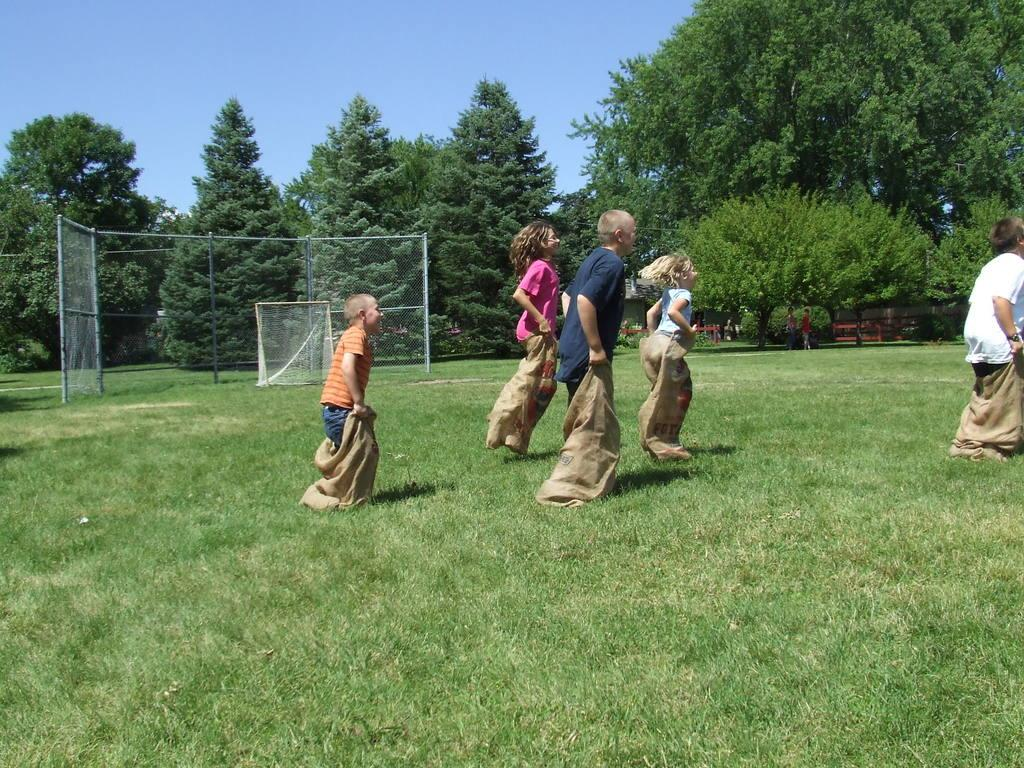What is the main setting of the image? There is an open grass ground in the image. What activity are the children engaged in on the grass ground? The children are doing a sack race on the grass ground. What can be seen in the background of the image? There are poles, trees, and people in the background of the image. What is visible in the sky in the image? The sky is visible in the background of the image. What type of silver object is being used by the boy in the image? There is no boy or silver object present in the image. What type of street is visible in the image? There is no street visible in the image; it features an open grass ground and background elements. 